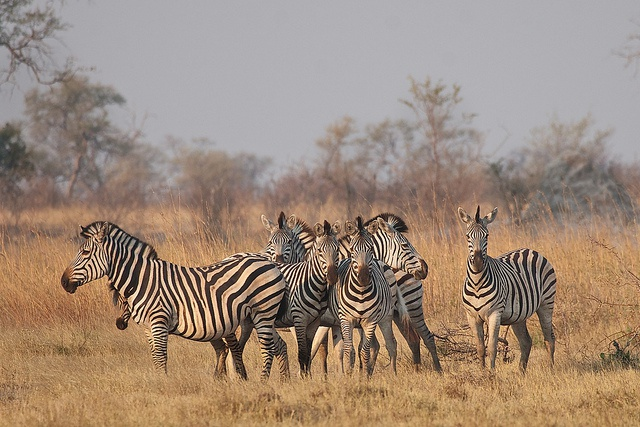Describe the objects in this image and their specific colors. I can see zebra in gray and black tones, zebra in gray, black, tan, and maroon tones, zebra in gray, black, and maroon tones, and zebra in gray, black, and tan tones in this image. 